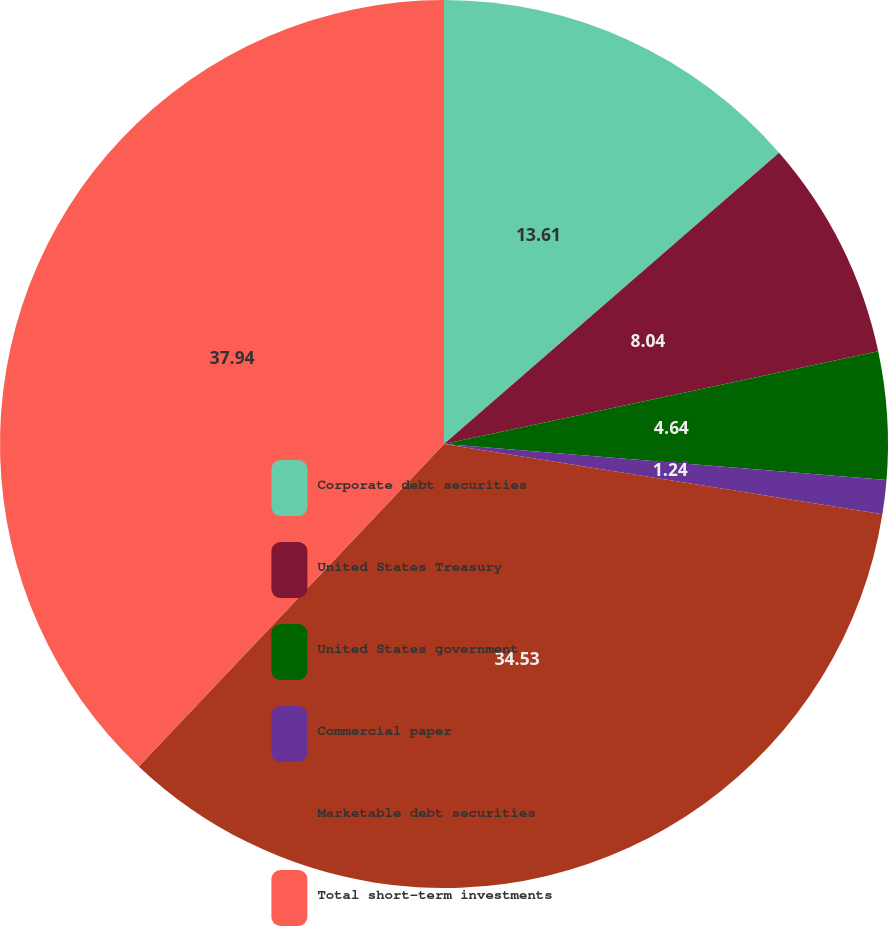<chart> <loc_0><loc_0><loc_500><loc_500><pie_chart><fcel>Corporate debt securities<fcel>United States Treasury<fcel>United States government<fcel>Commercial paper<fcel>Marketable debt securities<fcel>Total short-term investments<nl><fcel>13.61%<fcel>8.04%<fcel>4.64%<fcel>1.24%<fcel>34.53%<fcel>37.93%<nl></chart> 